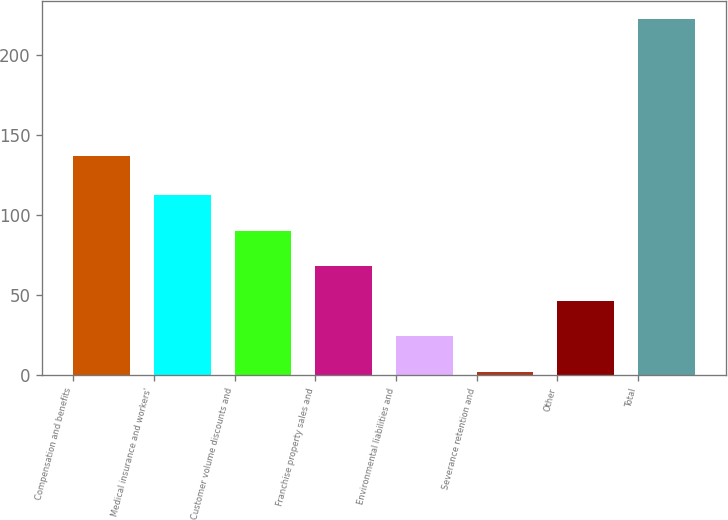Convert chart. <chart><loc_0><loc_0><loc_500><loc_500><bar_chart><fcel>Compensation and benefits<fcel>Medical insurance and workers'<fcel>Customer volume discounts and<fcel>Franchise property sales and<fcel>Environmental liabilities and<fcel>Severance retention and<fcel>Other<fcel>Total<nl><fcel>136.7<fcel>112.3<fcel>90.28<fcel>68.26<fcel>24.22<fcel>2.2<fcel>46.24<fcel>222.4<nl></chart> 